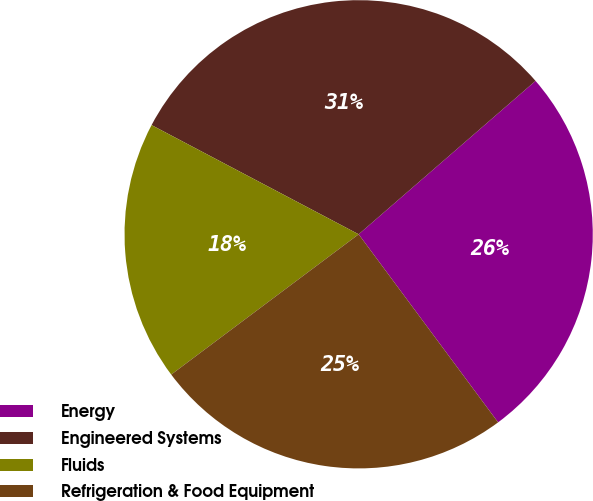Convert chart to OTSL. <chart><loc_0><loc_0><loc_500><loc_500><pie_chart><fcel>Energy<fcel>Engineered Systems<fcel>Fluids<fcel>Refrigeration & Food Equipment<nl><fcel>26.22%<fcel>30.91%<fcel>17.95%<fcel>24.93%<nl></chart> 